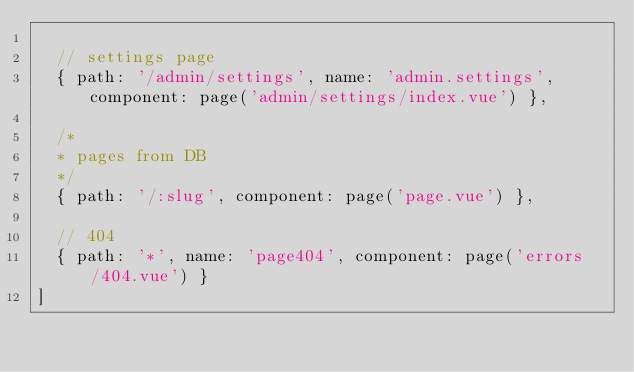<code> <loc_0><loc_0><loc_500><loc_500><_JavaScript_>
  // settings page
  { path: '/admin/settings', name: 'admin.settings', component: page('admin/settings/index.vue') },

  /*
  * pages from DB
  */
  { path: '/:slug', component: page('page.vue') },

  // 404
  { path: '*', name: 'page404', component: page('errors/404.vue') }
]
</code> 